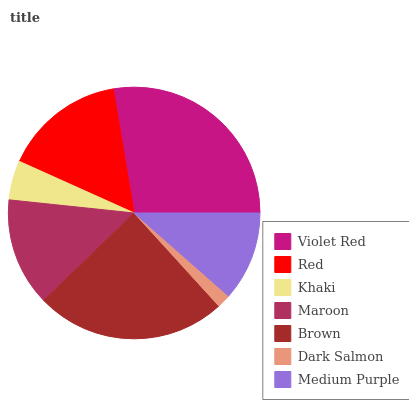Is Dark Salmon the minimum?
Answer yes or no. Yes. Is Violet Red the maximum?
Answer yes or no. Yes. Is Red the minimum?
Answer yes or no. No. Is Red the maximum?
Answer yes or no. No. Is Violet Red greater than Red?
Answer yes or no. Yes. Is Red less than Violet Red?
Answer yes or no. Yes. Is Red greater than Violet Red?
Answer yes or no. No. Is Violet Red less than Red?
Answer yes or no. No. Is Maroon the high median?
Answer yes or no. Yes. Is Maroon the low median?
Answer yes or no. Yes. Is Brown the high median?
Answer yes or no. No. Is Dark Salmon the low median?
Answer yes or no. No. 